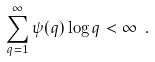<formula> <loc_0><loc_0><loc_500><loc_500>\sum _ { q = 1 } ^ { \infty } \psi ( q ) \log q < \infty \ .</formula> 